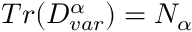Convert formula to latex. <formula><loc_0><loc_0><loc_500><loc_500>T r ( D _ { v a r } ^ { \alpha } ) = N _ { \alpha }</formula> 